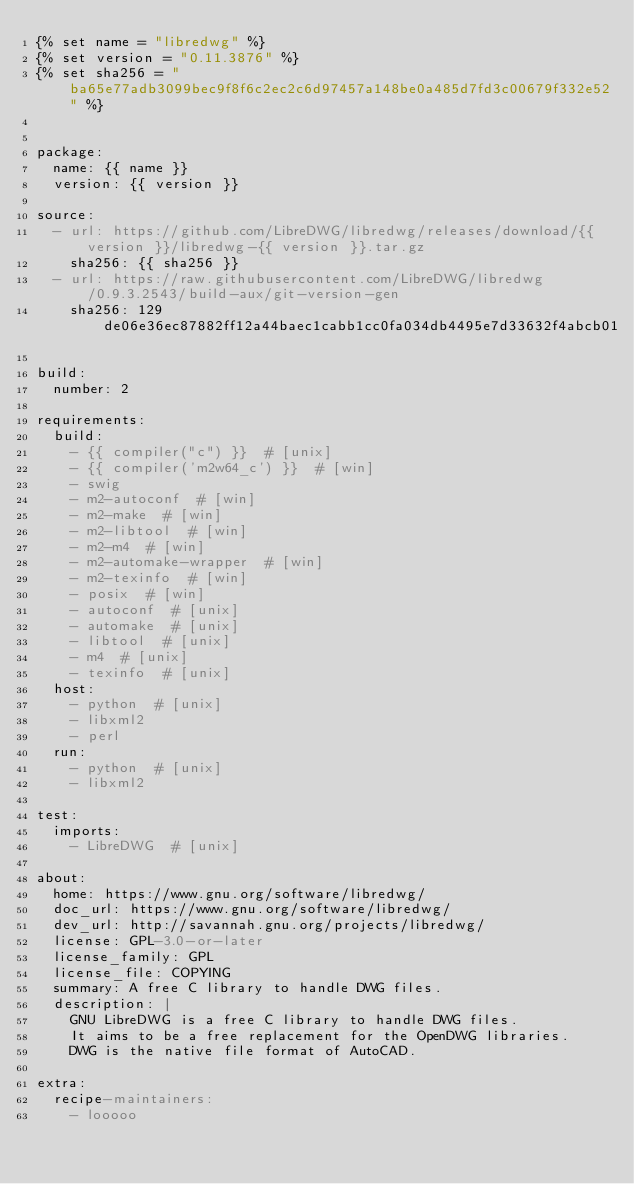<code> <loc_0><loc_0><loc_500><loc_500><_YAML_>{% set name = "libredwg" %}
{% set version = "0.11.3876" %}
{% set sha256 = "ba65e77adb3099bec9f8f6c2ec2c6d97457a148be0a485d7fd3c00679f332e52" %}


package:
  name: {{ name }}
  version: {{ version }}

source:
  - url: https://github.com/LibreDWG/libredwg/releases/download/{{ version }}/libredwg-{{ version }}.tar.gz
    sha256: {{ sha256 }}
  - url: https://raw.githubusercontent.com/LibreDWG/libredwg/0.9.3.2543/build-aux/git-version-gen
    sha256: 129de06e36ec87882ff12a44baec1cabb1cc0fa034db4495e7d33632f4abcb01

build:
  number: 2

requirements:
  build:
    - {{ compiler("c") }}  # [unix]
    - {{ compiler('m2w64_c') }}  # [win]
    - swig
    - m2-autoconf  # [win]
    - m2-make  # [win]
    - m2-libtool  # [win]
    - m2-m4  # [win]
    - m2-automake-wrapper  # [win]
    - m2-texinfo  # [win]
    - posix  # [win]
    - autoconf  # [unix]
    - automake  # [unix]
    - libtool  # [unix]
    - m4  # [unix]
    - texinfo  # [unix]
  host:
    - python  # [unix]
    - libxml2
    - perl
  run:
    - python  # [unix]
    - libxml2

test:
  imports:
    - LibreDWG  # [unix]

about:
  home: https://www.gnu.org/software/libredwg/
  doc_url: https://www.gnu.org/software/libredwg/
  dev_url: http://savannah.gnu.org/projects/libredwg/
  license: GPL-3.0-or-later
  license_family: GPL
  license_file: COPYING
  summary: A free C library to handle DWG files.
  description: |
    GNU LibreDWG is a free C library to handle DWG files.
    It aims to be a free replacement for the OpenDWG libraries.
    DWG is the native file format of AutoCAD.

extra:
  recipe-maintainers:
    - looooo
</code> 